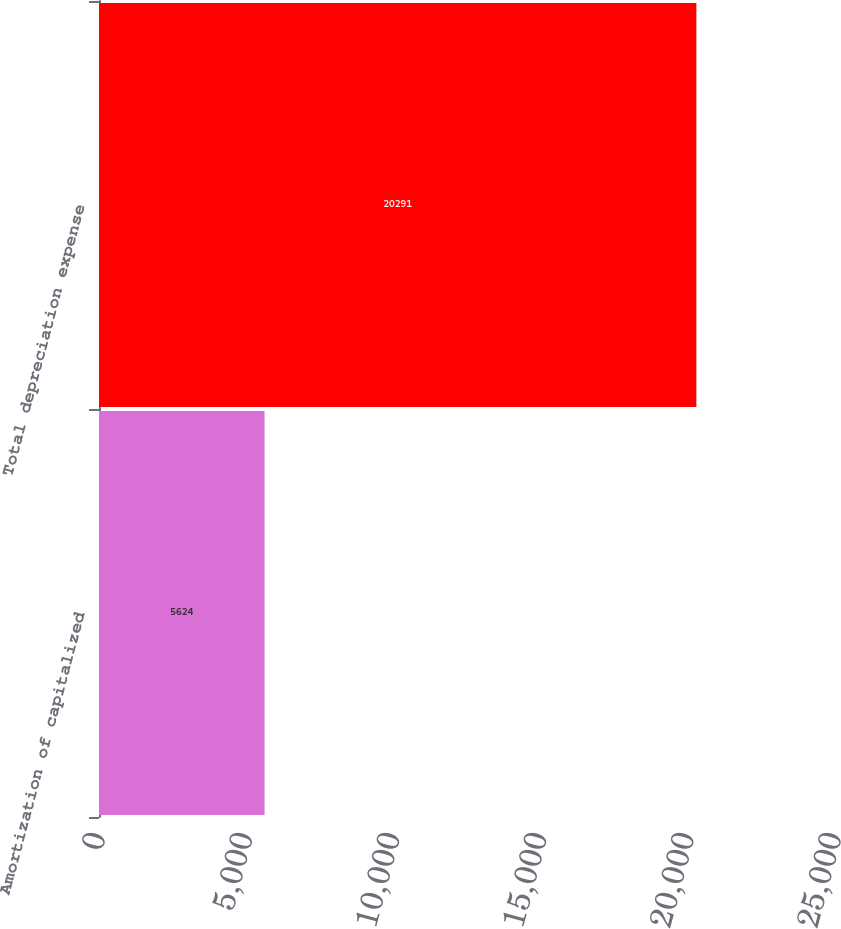Convert chart to OTSL. <chart><loc_0><loc_0><loc_500><loc_500><bar_chart><fcel>Amortization of capitalized<fcel>Total depreciation expense<nl><fcel>5624<fcel>20291<nl></chart> 